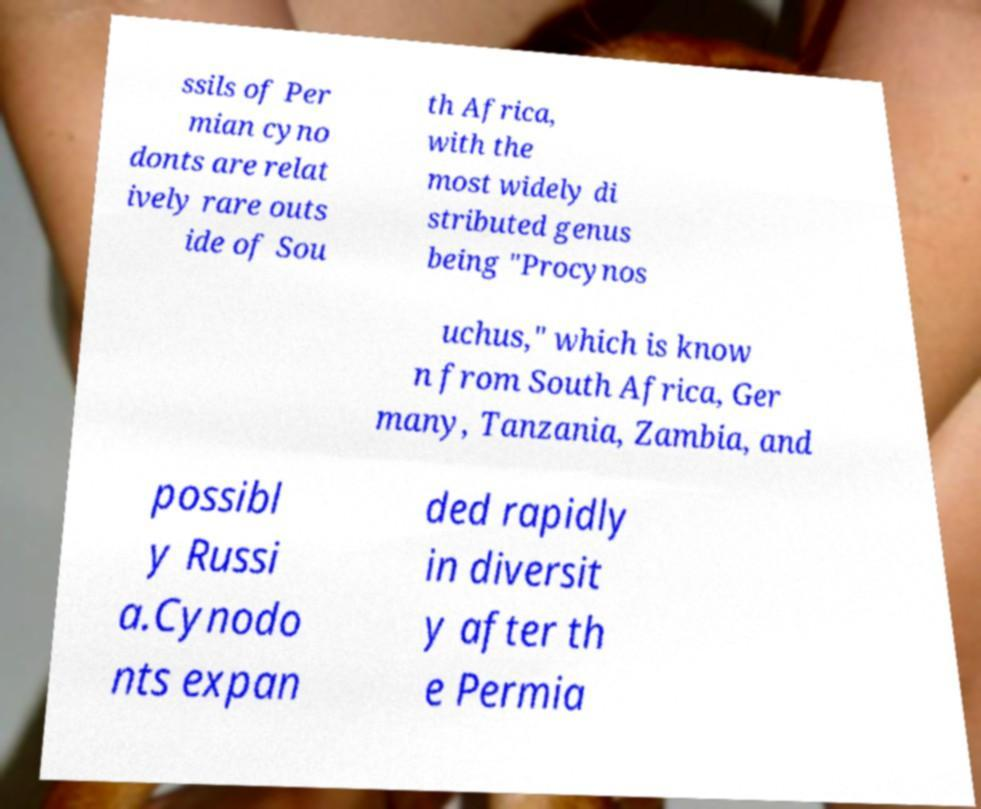Please identify and transcribe the text found in this image. ssils of Per mian cyno donts are relat ively rare outs ide of Sou th Africa, with the most widely di stributed genus being "Procynos uchus," which is know n from South Africa, Ger many, Tanzania, Zambia, and possibl y Russi a.Cynodo nts expan ded rapidly in diversit y after th e Permia 